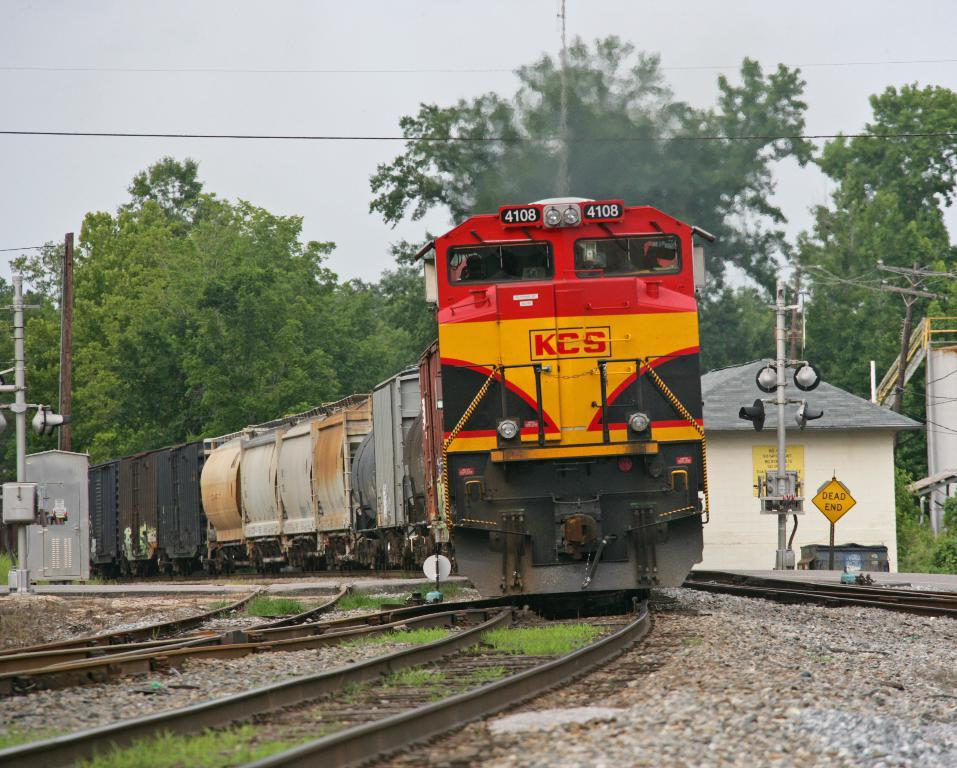What is the main subject of the image? The main subject of the image is a train. Where is the train located in the image? The train is on a track. What can be seen in the background of the image? There are trees visible in the background of the image. What else is visible in the image besides the train and trees? The sky is visible in the image. Can you tell me how many baskets are hanging from the train in the image? There are no baskets hanging from the train in the image. What type of knife is being used by the train's conductor in the image? There is no conductor or knife present in the image; it features a train on a track with trees and the sky visible in the background. 